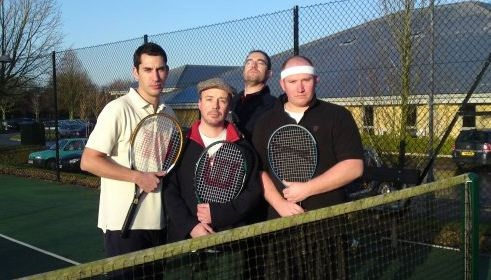Describe the objects in this image and their specific colors. I can see people in gray, black, and salmon tones, people in gray, beige, black, and tan tones, people in gray, black, salmon, and brown tones, tennis racket in gray, black, darkgray, and beige tones, and tennis racket in gray, black, and darkgray tones in this image. 